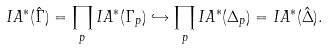<formula> <loc_0><loc_0><loc_500><loc_500>I A ^ { * } ( \hat { \Gamma } ) & = \prod _ { p } I A ^ { * } ( \Gamma _ { p } ) \hookrightarrow \prod _ { p } I A ^ { * } ( \Delta _ { p } ) = I A ^ { * } ( \hat { \Delta } ) .</formula> 